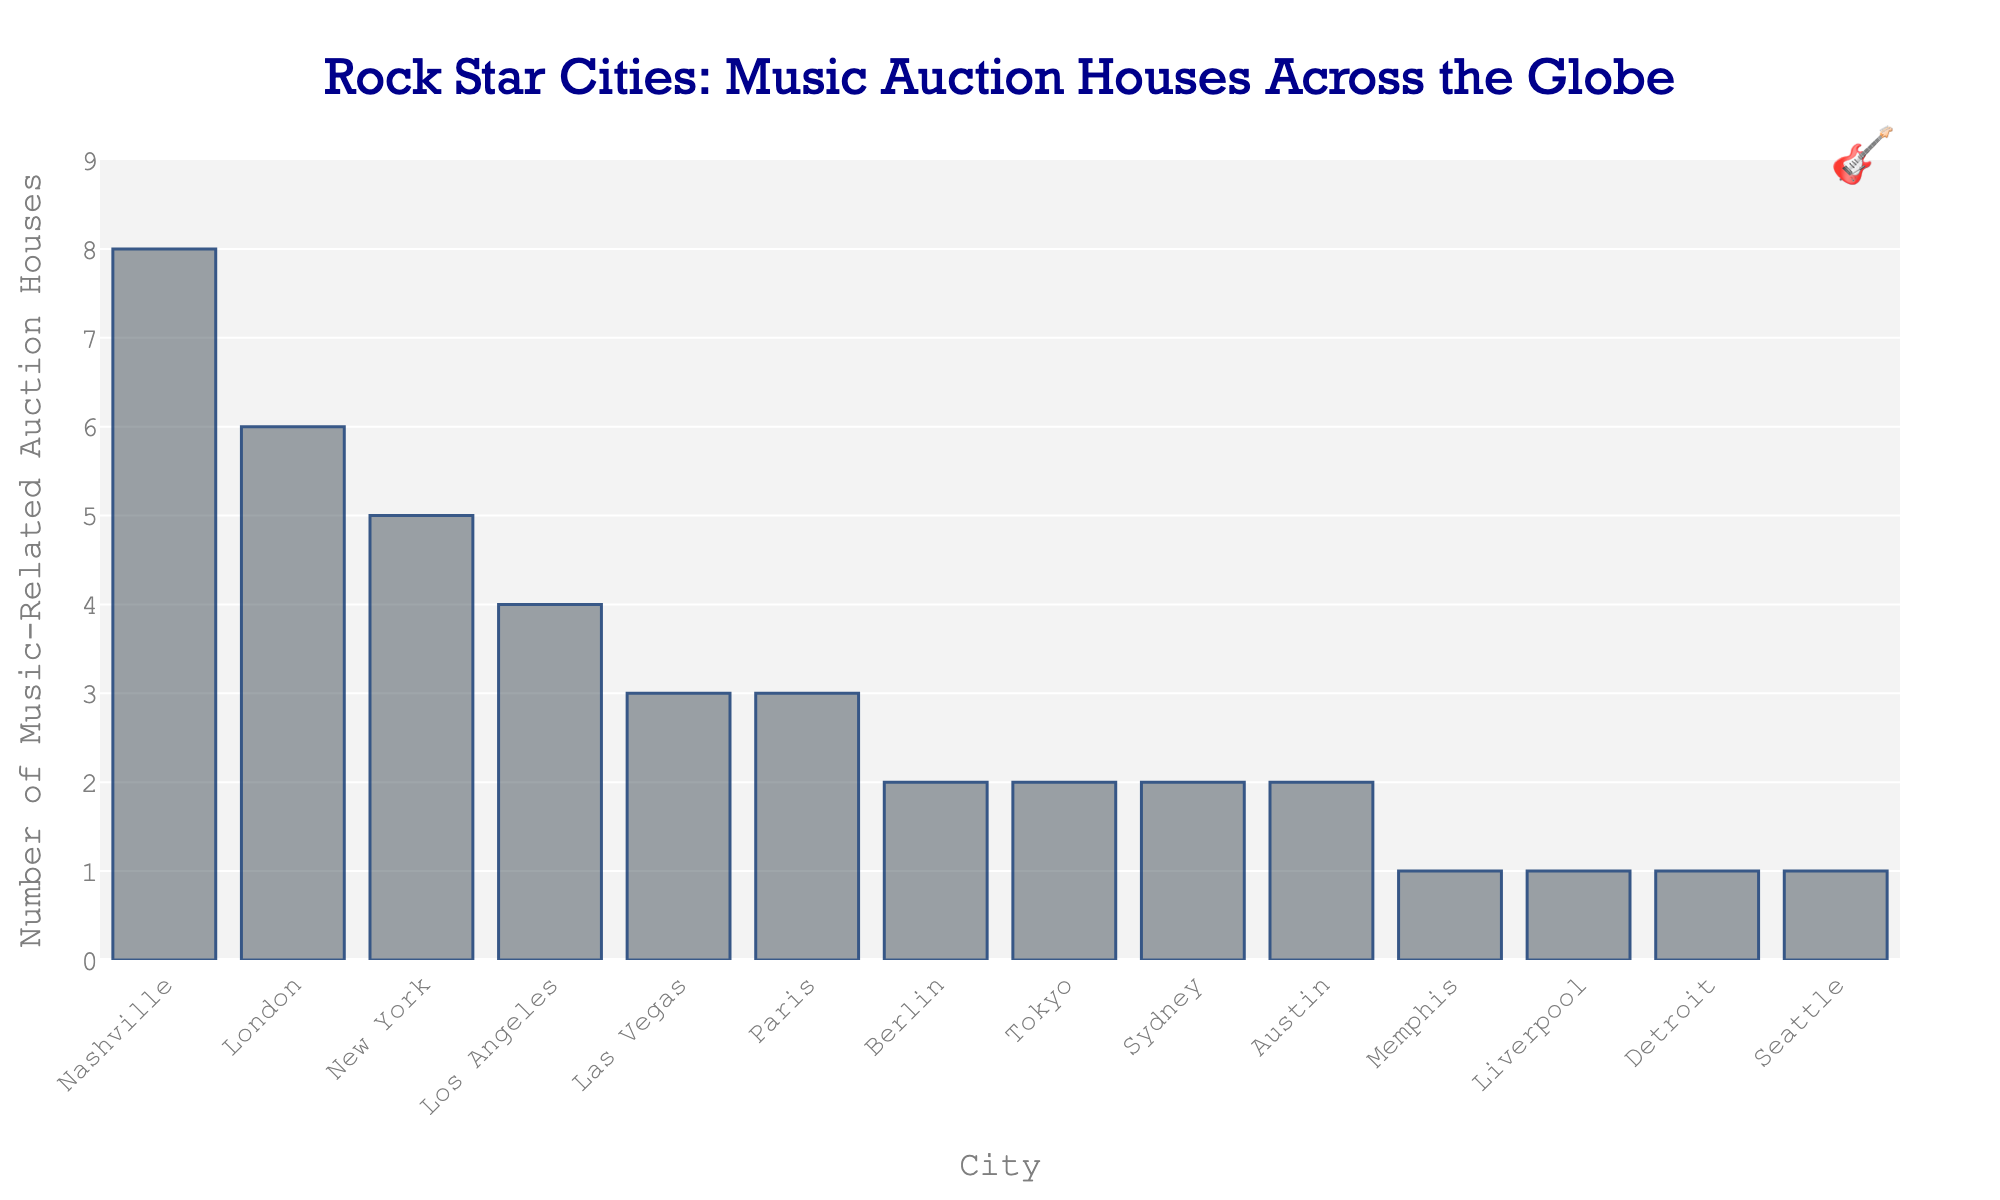What's the total number of music-related auction houses in Paris and Berlin combined? There are 3 auction houses in Paris and 2 in Berlin. Adding these together gives us 3 + 2 = 5.
Answer: 5 Which city has more music-related auction houses, Los Angeles or Tokyo? Los Angeles has 4 music-related auction houses while Tokyo has 2. Since 4 is greater than 2, Los Angeles has more.
Answer: Los Angeles How many more music-related auction houses does Nashville have compared to Seattle? Nashville has 8 music-related auction houses, and Seattle has 1. The difference is 8 - 1 = 7.
Answer: 7 What is the median number of music-related auction houses across all the cities? The ordered list of values is: 1, 1, 1, 1, 2, 2, 2, 3, 3, 4, 5, 6, 8. The median value is the middle value, which is 2 (since it's the 7th value in a list of 13 values).
Answer: 2 How many cities have exactly 1 music-related auction house? From the bar chart, it is visible that Memphis, Liverpool, Detroit, and Seattle each have 1 auction house. There are 4 such cities.
Answer: 4 Which city hosts the highest number of music-related auction houses? According to the figure, Nashville hosts the highest number, with 8 auction houses.
Answer: Nashville Are there more cities with 2 music-related auction houses or 3? From the chart, the cities with 2 auction houses are Berlin, Tokyo, Sydney, and Austin (4 cities in total), and the cities with 3 auction houses are Las Vegas and Paris (2 cities in total). Since 4 > 2, there are more cities with 2 auction houses.
Answer: More cities with 2 What's the average number of music-related auction houses per city? There are 14 cities in total. Summing up all auction houses gives 8 + 6 + 5 + 4 + 3 + 3 + 2 + 2 + 2 + 2 + 1 + 1 + 1 + 1 = 41. Averaging this over 14 cities gives 41 / 14 ≈ 2.93.
Answer: Approximately 2.93 How many auction houses are there in cities with a guitar icon annotation? The guitar icon annotation is placed in a corner for stylization and does not indicate a specific city.
Answer: Not applicable What is the sum of music-related auction houses in cities with names starting with 'L'? The cities are London (6), Los Angeles (4), and Liverpool (1). Summing these gives 6 + 4 + 1 = 11.
Answer: 11 